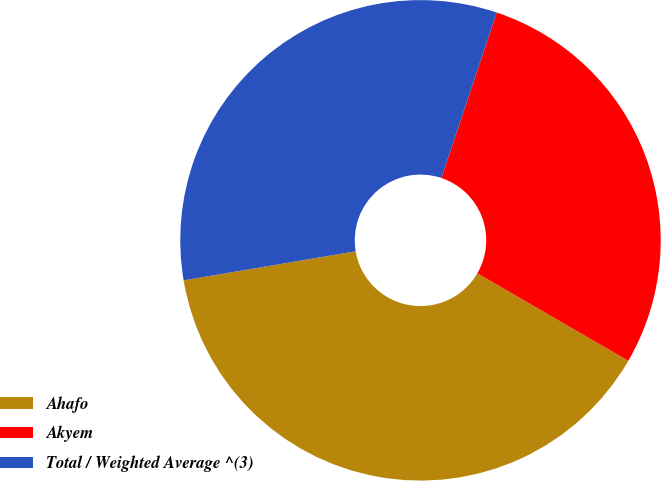<chart> <loc_0><loc_0><loc_500><loc_500><pie_chart><fcel>Ahafo<fcel>Akyem<fcel>Total / Weighted Average ^(3)<nl><fcel>38.97%<fcel>28.22%<fcel>32.81%<nl></chart> 